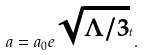<formula> <loc_0><loc_0><loc_500><loc_500>a = a _ { 0 } e ^ { \sqrt { \Lambda / 3 } t } .</formula> 